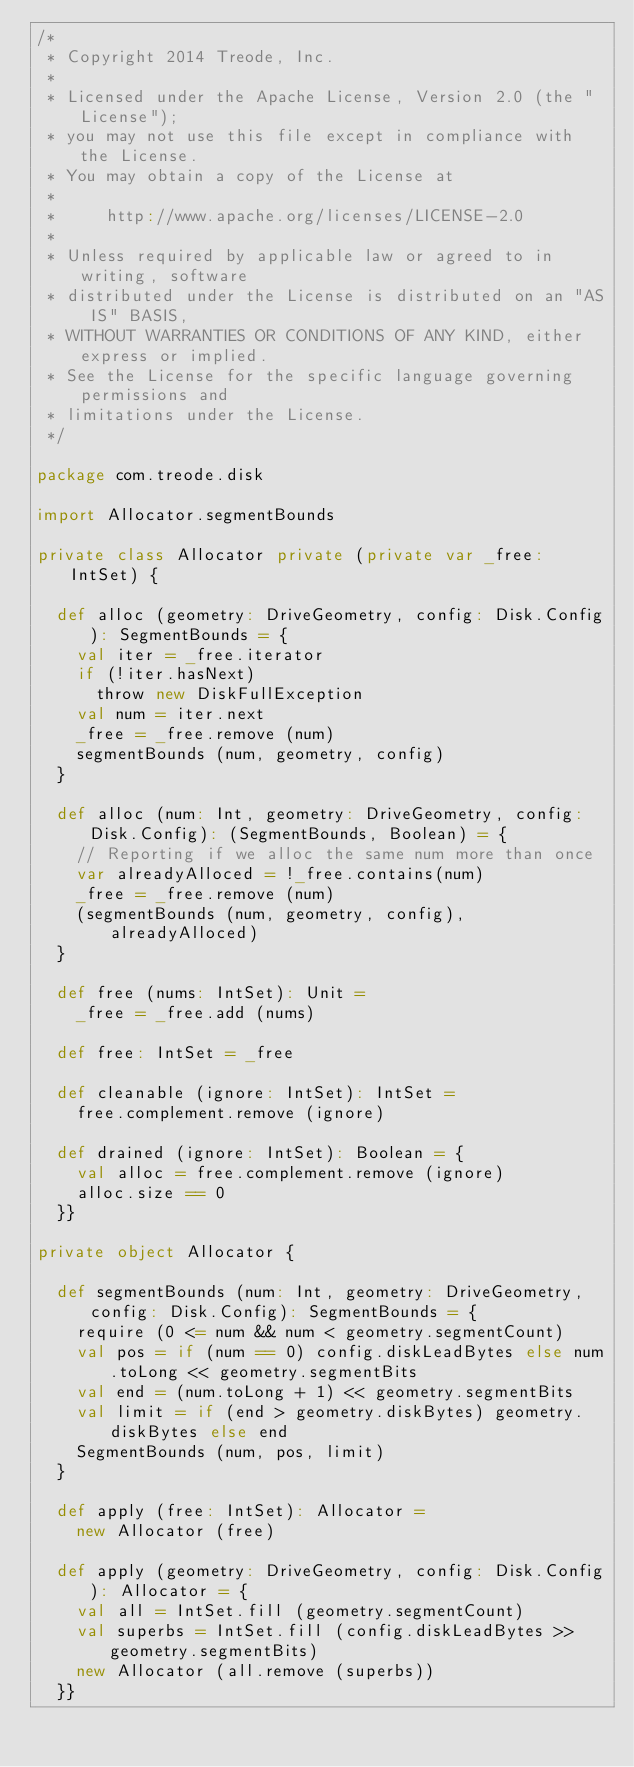Convert code to text. <code><loc_0><loc_0><loc_500><loc_500><_Scala_>/*
 * Copyright 2014 Treode, Inc.
 *
 * Licensed under the Apache License, Version 2.0 (the "License");
 * you may not use this file except in compliance with the License.
 * You may obtain a copy of the License at
 *
 *     http://www.apache.org/licenses/LICENSE-2.0
 *
 * Unless required by applicable law or agreed to in writing, software
 * distributed under the License is distributed on an "AS IS" BASIS,
 * WITHOUT WARRANTIES OR CONDITIONS OF ANY KIND, either express or implied.
 * See the License for the specific language governing permissions and
 * limitations under the License.
 */

package com.treode.disk

import Allocator.segmentBounds

private class Allocator private (private var _free: IntSet) {

  def alloc (geometry: DriveGeometry, config: Disk.Config): SegmentBounds = {
    val iter = _free.iterator
    if (!iter.hasNext)
      throw new DiskFullException
    val num = iter.next
    _free = _free.remove (num)
    segmentBounds (num, geometry, config)
  }

  def alloc (num: Int, geometry: DriveGeometry, config: Disk.Config): (SegmentBounds, Boolean) = {
    // Reporting if we alloc the same num more than once
    var alreadyAlloced = !_free.contains(num)
    _free = _free.remove (num)
    (segmentBounds (num, geometry, config), alreadyAlloced)
  }

  def free (nums: IntSet): Unit =
    _free = _free.add (nums)

  def free: IntSet = _free

  def cleanable (ignore: IntSet): IntSet =
    free.complement.remove (ignore)

  def drained (ignore: IntSet): Boolean = {
    val alloc = free.complement.remove (ignore)
    alloc.size == 0
  }}

private object Allocator {

  def segmentBounds (num: Int, geometry: DriveGeometry, config: Disk.Config): SegmentBounds = {
    require (0 <= num && num < geometry.segmentCount)
    val pos = if (num == 0) config.diskLeadBytes else num.toLong << geometry.segmentBits
    val end = (num.toLong + 1) << geometry.segmentBits
    val limit = if (end > geometry.diskBytes) geometry.diskBytes else end
    SegmentBounds (num, pos, limit)
  }

  def apply (free: IntSet): Allocator =
    new Allocator (free)

  def apply (geometry: DriveGeometry, config: Disk.Config): Allocator = {
    val all = IntSet.fill (geometry.segmentCount)
    val superbs = IntSet.fill (config.diskLeadBytes >> geometry.segmentBits)
    new Allocator (all.remove (superbs))
  }}
</code> 